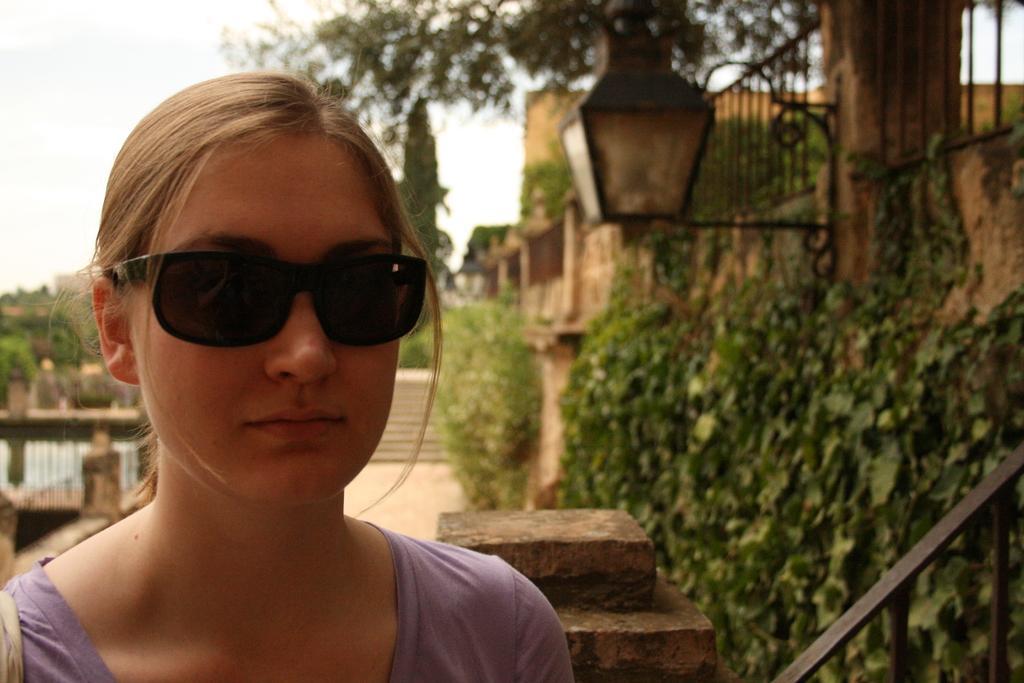Describe this image in one or two sentences. In this image we can see a woman with goggles to her eyes. In the background we can see railings, plants, light on the wall, steps, buildings and sky. 